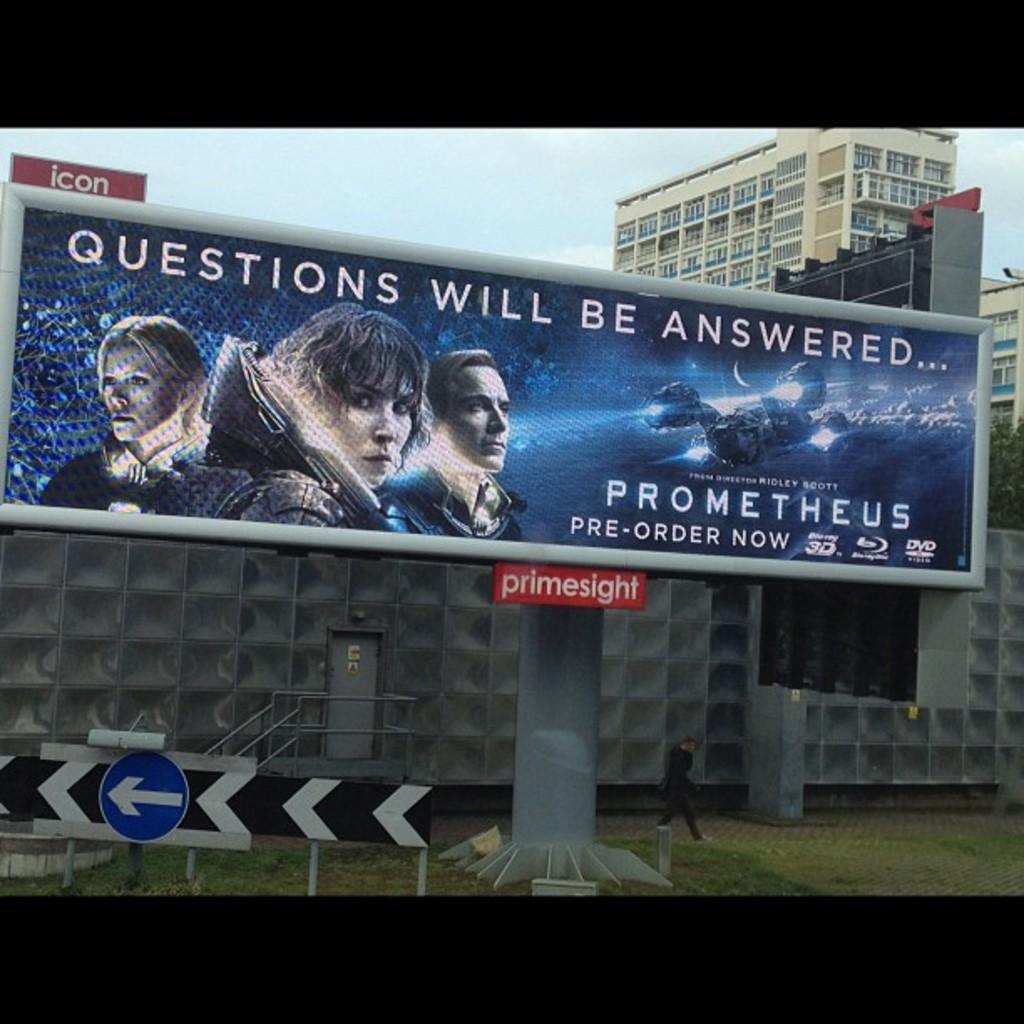<image>
Render a clear and concise summary of the photo. A billboard advertising the movie Prometheus, claiming questions will be answered. 